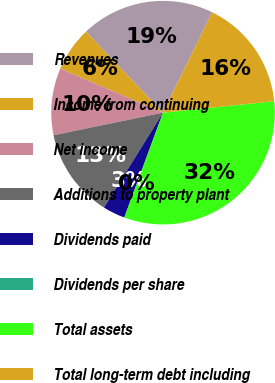<chart> <loc_0><loc_0><loc_500><loc_500><pie_chart><fcel>Revenues<fcel>Income from continuing<fcel>Net income<fcel>Additions to property plant<fcel>Dividends paid<fcel>Dividends per share<fcel>Total assets<fcel>Total long-term debt including<nl><fcel>19.35%<fcel>6.45%<fcel>9.68%<fcel>12.9%<fcel>3.23%<fcel>0.0%<fcel>32.26%<fcel>16.13%<nl></chart> 